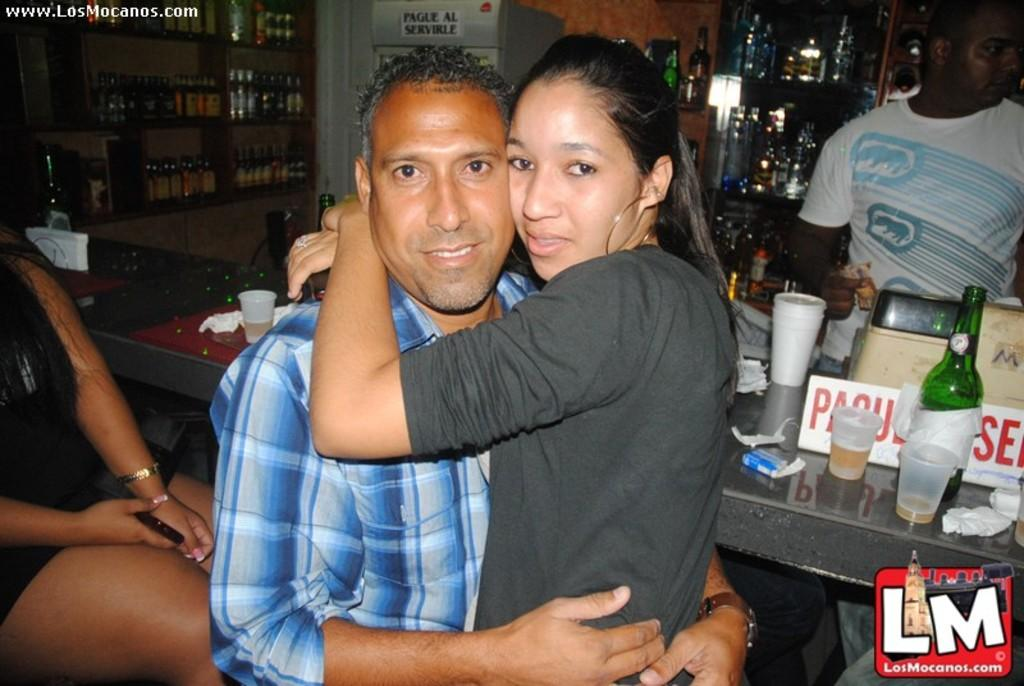What are the two persons in the image doing? The two persons in the image are hugging. What can be seen on the rack in the image? There is a rack filled with bottles in the image. What is on the table in the image? There is a table with a bottle and glasses in the image. What is the woman in the image doing? The woman is sitting on a chair and holding a mobile. What level of ornamentation does the beginner class have in the image? There is no mention of a class or ornamentation in the image; it features two persons hugging, a rack filled with bottles, a table with a bottle and glasses, and a woman sitting on a chair holding a mobile. 